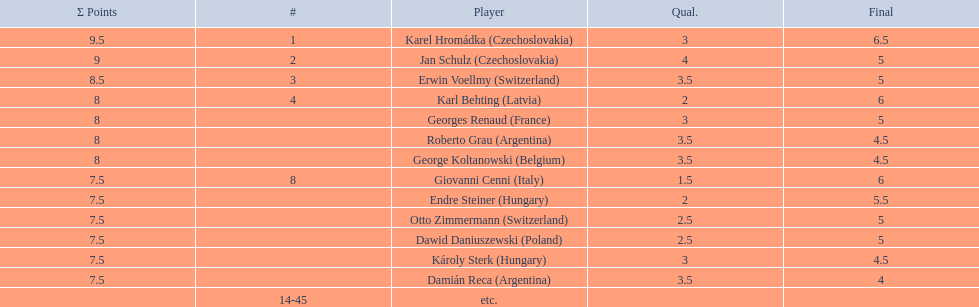What number of players achieved 8 points? 4. 